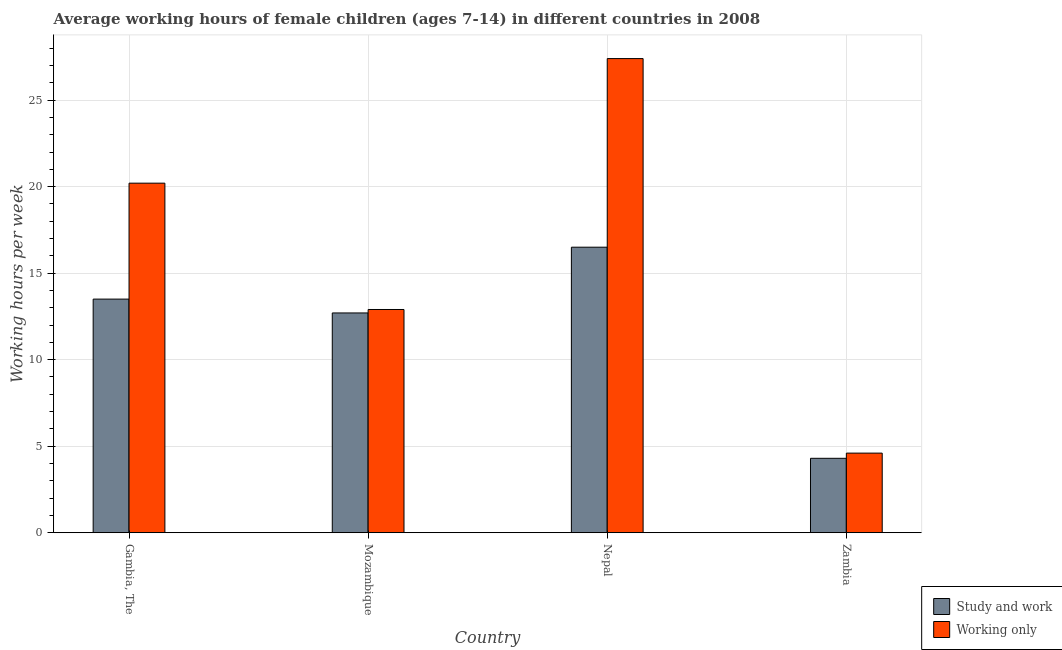How many groups of bars are there?
Offer a terse response. 4. Are the number of bars per tick equal to the number of legend labels?
Keep it short and to the point. Yes. How many bars are there on the 4th tick from the left?
Provide a succinct answer. 2. What is the label of the 2nd group of bars from the left?
Keep it short and to the point. Mozambique. What is the average working hour of children involved in only work in Nepal?
Your answer should be compact. 27.4. Across all countries, what is the maximum average working hour of children involved in only work?
Offer a very short reply. 27.4. Across all countries, what is the minimum average working hour of children involved in only work?
Ensure brevity in your answer.  4.6. In which country was the average working hour of children involved in study and work maximum?
Your answer should be very brief. Nepal. In which country was the average working hour of children involved in only work minimum?
Your response must be concise. Zambia. What is the total average working hour of children involved in study and work in the graph?
Provide a succinct answer. 47. What is the average average working hour of children involved in study and work per country?
Provide a succinct answer. 11.75. What is the difference between the average working hour of children involved in only work and average working hour of children involved in study and work in Zambia?
Ensure brevity in your answer.  0.3. In how many countries, is the average working hour of children involved in only work greater than 14 hours?
Provide a succinct answer. 2. What is the ratio of the average working hour of children involved in only work in Gambia, The to that in Mozambique?
Provide a succinct answer. 1.57. Is the average working hour of children involved in only work in Nepal less than that in Zambia?
Keep it short and to the point. No. Is the difference between the average working hour of children involved in only work in Mozambique and Zambia greater than the difference between the average working hour of children involved in study and work in Mozambique and Zambia?
Keep it short and to the point. No. What is the difference between the highest and the second highest average working hour of children involved in only work?
Your answer should be compact. 7.2. What does the 1st bar from the left in Nepal represents?
Offer a very short reply. Study and work. What does the 1st bar from the right in Mozambique represents?
Your answer should be very brief. Working only. Are the values on the major ticks of Y-axis written in scientific E-notation?
Offer a terse response. No. Does the graph contain grids?
Your answer should be compact. Yes. Where does the legend appear in the graph?
Your answer should be compact. Bottom right. What is the title of the graph?
Provide a short and direct response. Average working hours of female children (ages 7-14) in different countries in 2008. Does "Electricity and heat production" appear as one of the legend labels in the graph?
Provide a short and direct response. No. What is the label or title of the Y-axis?
Give a very brief answer. Working hours per week. What is the Working hours per week of Working only in Gambia, The?
Your answer should be compact. 20.2. What is the Working hours per week in Study and work in Nepal?
Your response must be concise. 16.5. What is the Working hours per week in Working only in Nepal?
Your answer should be compact. 27.4. What is the Working hours per week of Working only in Zambia?
Provide a short and direct response. 4.6. Across all countries, what is the maximum Working hours per week of Study and work?
Offer a terse response. 16.5. Across all countries, what is the maximum Working hours per week in Working only?
Your answer should be very brief. 27.4. Across all countries, what is the minimum Working hours per week in Working only?
Your answer should be compact. 4.6. What is the total Working hours per week of Working only in the graph?
Your answer should be very brief. 65.1. What is the difference between the Working hours per week of Study and work in Gambia, The and that in Mozambique?
Provide a short and direct response. 0.8. What is the difference between the Working hours per week in Study and work in Gambia, The and that in Nepal?
Keep it short and to the point. -3. What is the difference between the Working hours per week in Study and work in Gambia, The and that in Zambia?
Your answer should be very brief. 9.2. What is the difference between the Working hours per week in Study and work in Mozambique and that in Nepal?
Give a very brief answer. -3.8. What is the difference between the Working hours per week in Study and work in Mozambique and that in Zambia?
Your response must be concise. 8.4. What is the difference between the Working hours per week of Working only in Mozambique and that in Zambia?
Provide a short and direct response. 8.3. What is the difference between the Working hours per week of Working only in Nepal and that in Zambia?
Offer a very short reply. 22.8. What is the difference between the Working hours per week of Study and work in Gambia, The and the Working hours per week of Working only in Nepal?
Provide a succinct answer. -13.9. What is the difference between the Working hours per week in Study and work in Gambia, The and the Working hours per week in Working only in Zambia?
Give a very brief answer. 8.9. What is the difference between the Working hours per week of Study and work in Mozambique and the Working hours per week of Working only in Nepal?
Provide a succinct answer. -14.7. What is the average Working hours per week of Study and work per country?
Provide a short and direct response. 11.75. What is the average Working hours per week of Working only per country?
Ensure brevity in your answer.  16.27. What is the difference between the Working hours per week in Study and work and Working hours per week in Working only in Gambia, The?
Provide a succinct answer. -6.7. What is the difference between the Working hours per week of Study and work and Working hours per week of Working only in Nepal?
Offer a very short reply. -10.9. What is the ratio of the Working hours per week in Study and work in Gambia, The to that in Mozambique?
Give a very brief answer. 1.06. What is the ratio of the Working hours per week of Working only in Gambia, The to that in Mozambique?
Give a very brief answer. 1.57. What is the ratio of the Working hours per week in Study and work in Gambia, The to that in Nepal?
Your answer should be very brief. 0.82. What is the ratio of the Working hours per week of Working only in Gambia, The to that in Nepal?
Ensure brevity in your answer.  0.74. What is the ratio of the Working hours per week of Study and work in Gambia, The to that in Zambia?
Give a very brief answer. 3.14. What is the ratio of the Working hours per week of Working only in Gambia, The to that in Zambia?
Give a very brief answer. 4.39. What is the ratio of the Working hours per week in Study and work in Mozambique to that in Nepal?
Your response must be concise. 0.77. What is the ratio of the Working hours per week in Working only in Mozambique to that in Nepal?
Offer a terse response. 0.47. What is the ratio of the Working hours per week in Study and work in Mozambique to that in Zambia?
Offer a very short reply. 2.95. What is the ratio of the Working hours per week in Working only in Mozambique to that in Zambia?
Your response must be concise. 2.8. What is the ratio of the Working hours per week in Study and work in Nepal to that in Zambia?
Keep it short and to the point. 3.84. What is the ratio of the Working hours per week of Working only in Nepal to that in Zambia?
Ensure brevity in your answer.  5.96. What is the difference between the highest and the second highest Working hours per week in Study and work?
Ensure brevity in your answer.  3. What is the difference between the highest and the second highest Working hours per week in Working only?
Provide a succinct answer. 7.2. What is the difference between the highest and the lowest Working hours per week of Working only?
Keep it short and to the point. 22.8. 